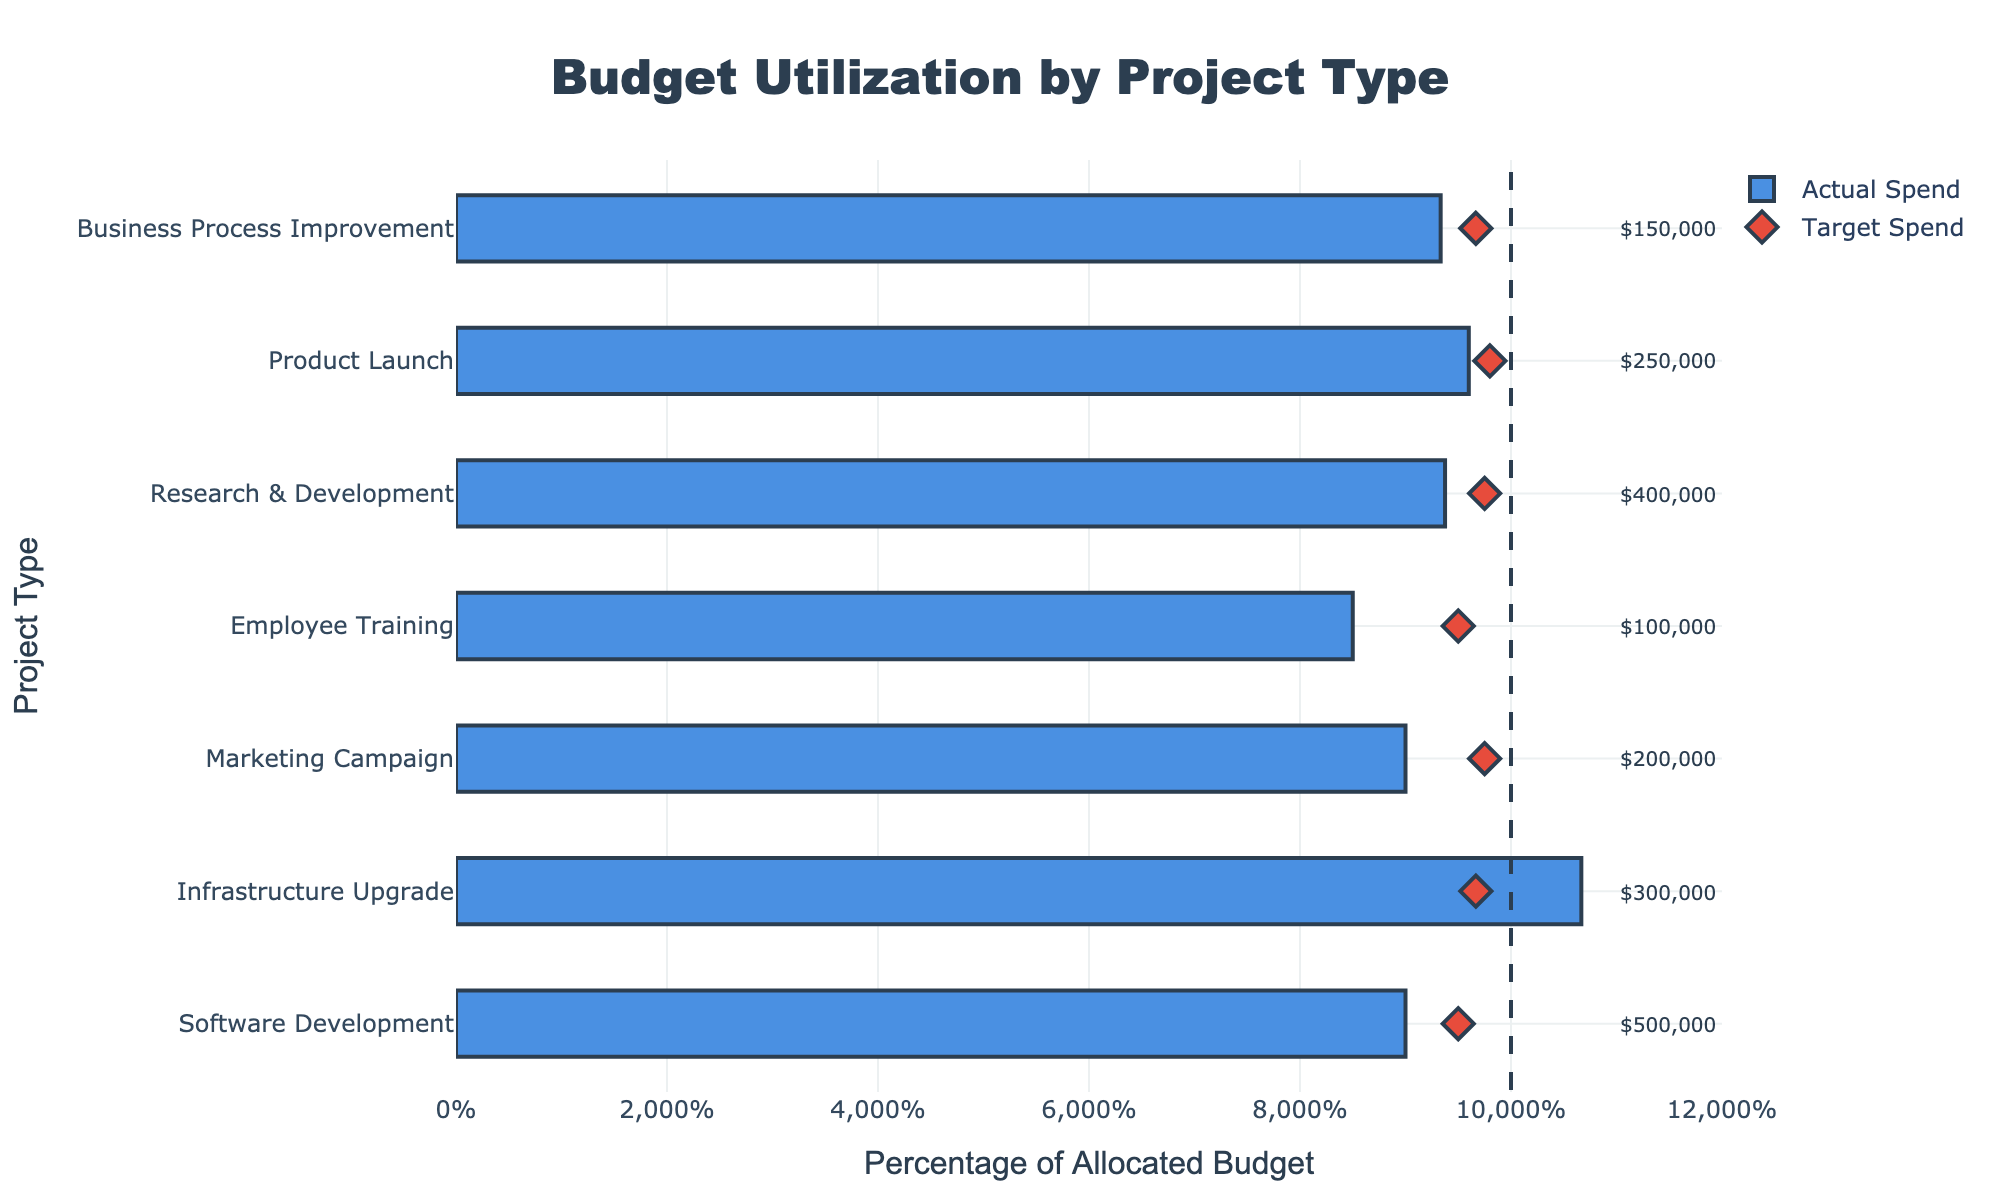What is the title of the figure? The title is prominently displayed at the top of the chart. It indicates the main subject of the figure.
Answer: Budget Utilization by Project Type What is the x-axis title? The title for the x-axis is shown horizontally at the bottom of the chart. It helps to understand what the horizontal bars represent.
Answer: Percentage of Allocated Budget Which project type has the highest allocated budget? To determine this, look at the annotations on the right side of the figure which show the allocated budgets for each project type.
Answer: Software Development Are there any projects where the actual spend exceeds the allocated budget? To answer this, compare the length of the bars (actual spend as a percentage of allocated budget) to 100%. Bars extending beyond the 100% line indicate overspending.
Answer: Yes, Infrastructure Upgrade Which project had the lowest percentage of actual spend compared to its allocated budget? Look at the horizontal bars and compare their lengths. The shortest bar represents the lowest percentage spent.
Answer: Employee Training How does the actual spend for the Marketing Campaign compare to its target spend? Identify the bar (blue) for Marketing Campaign and the diamond marker (red) for its target spend. Compare their positions on the x-axis.
Answer: Actual spend is less than target spend What is the combined actual spend for Research & Development and Product Launch? Add the actual spends for both projects ($375,000 for Research & Development and $240,000 for Product Launch).
Answer: $615,000 How far is the actual spend from the target in Software Development? Subtract the target spend for Software Development ($475,000) from the actual spend ($450,000).
Answer: $25,000 below target Which project type's actual spend is closest to its target spend? Check the distance between the blue bar and the red diamond marker for each project. The smallest distance indicates the closest spend to target.
Answer: Product Launch How many project types are displayed in the chart? Count the number of rows or categories listed along the y-axis.
Answer: 7 